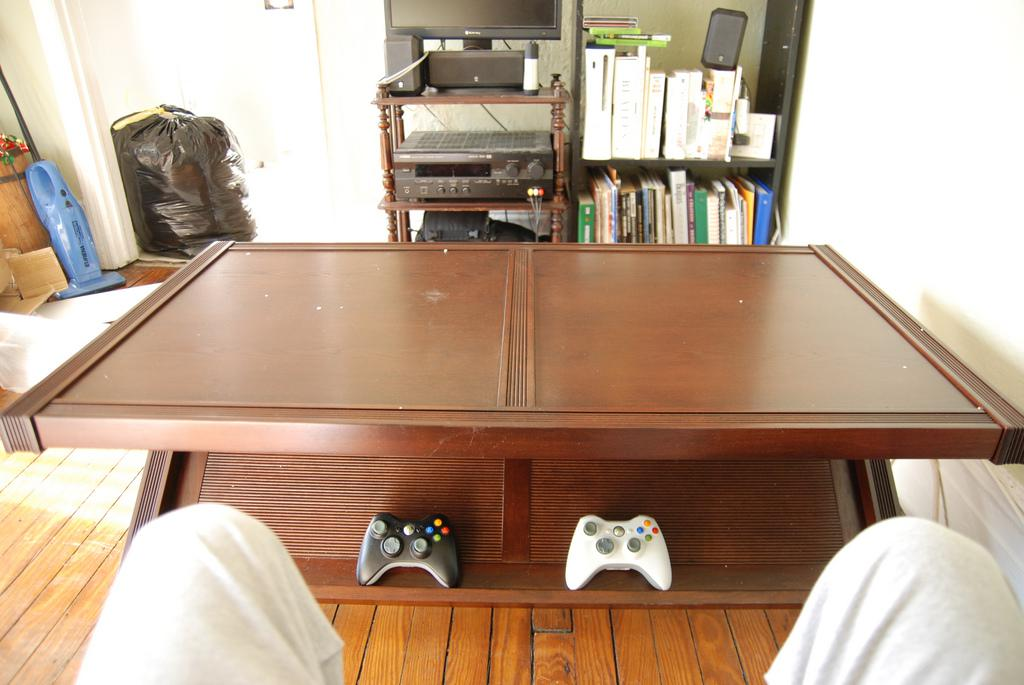Question: when was the photo taken?
Choices:
A. Sunrise.
B. Sunset.
C. At night.
D. During the day.
Answer with the letter. Answer: D Question: why is there a table?
Choices:
A. It looks nice.
B. It came with the other furniture.
C. It came with the house.
D. To hold things.
Answer with the letter. Answer: D Question: what is on the bottom part of the table?
Choices:
A. Food.
B. Drinks.
C. Forks.
D. Xbox controllers.
Answer with the letter. Answer: D Question: who took the photo?
Choices:
A. A doctor.
B. A person in the room.
C. A robot.
D. A fireman.
Answer with the letter. Answer: B Question: what is the floor made of?
Choices:
A. Dirt.
B. Wooden planking.
C. Concrete.
D. Tile.
Answer with the letter. Answer: B Question: where are the books?
Choices:
A. Stacked on the floor.
B. In the girl's lap.
C. In a backpack.
D. On a shelf.
Answer with the letter. Answer: D Question: where was the photo taken?
Choices:
A. At a dorm.
B. In a living room.
C. At an office.
D. At a conference room.
Answer with the letter. Answer: B Question: where was the picture taken?
Choices:
A. Living room.
B. Bathroom.
C. Kitchen.
D. Bedroom.
Answer with the letter. Answer: A Question: what color is the vacuum?
Choices:
A. Red.
B. Blue.
C. Black.
D. Green.
Answer with the letter. Answer: B Question: what part of the person is visible?
Choices:
A. Feet.
B. Their knees.
C. Hand.
D. Eyes.
Answer with the letter. Answer: B Question: what's the corner?
Choices:
A. A black garbage bag.
B. A house.
C. A dog.
D. A building.
Answer with the letter. Answer: A Question: what is on the tv stand?
Choices:
A. Magazines.
B. Pamphlets.
C. Notebook.
D. Books.
Answer with the letter. Answer: D Question: what body parts are visible?
Choices:
A. A man's knees.
B. There feet.
C. There lips.
D. There elbows.
Answer with the letter. Answer: A Question: how would you describe the size of the wooden table?
Choices:
A. Short and small.
B. Long.
C. Wide.
D. Average.
Answer with the letter. Answer: C Question: what is the table made of?
Choices:
A. Glass.
B. Metal.
C. Marble.
D. Wood.
Answer with the letter. Answer: D 